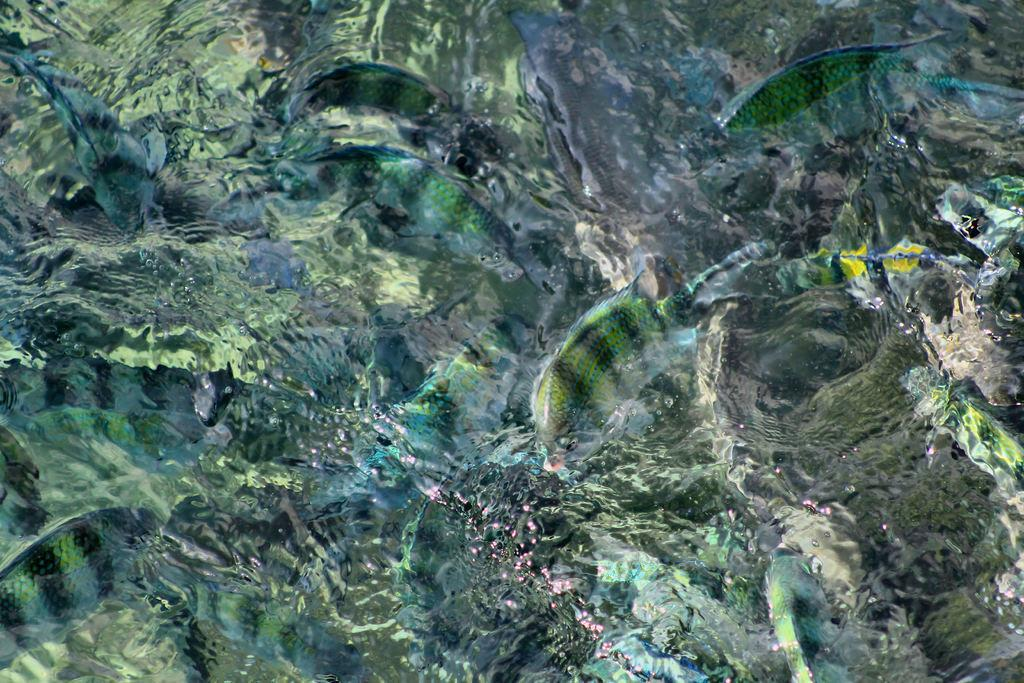What type of animals can be seen in the image? There are many fishes in the image. What are the fishes doing in the image? The fishes are swimming in the water. What type of steel structure can be seen in the image? There is no steel structure present in the image; it features many fishes swimming in the water. How many cats are visible in the image? There are no cats present in the image; it features many fishes swimming in the water. 